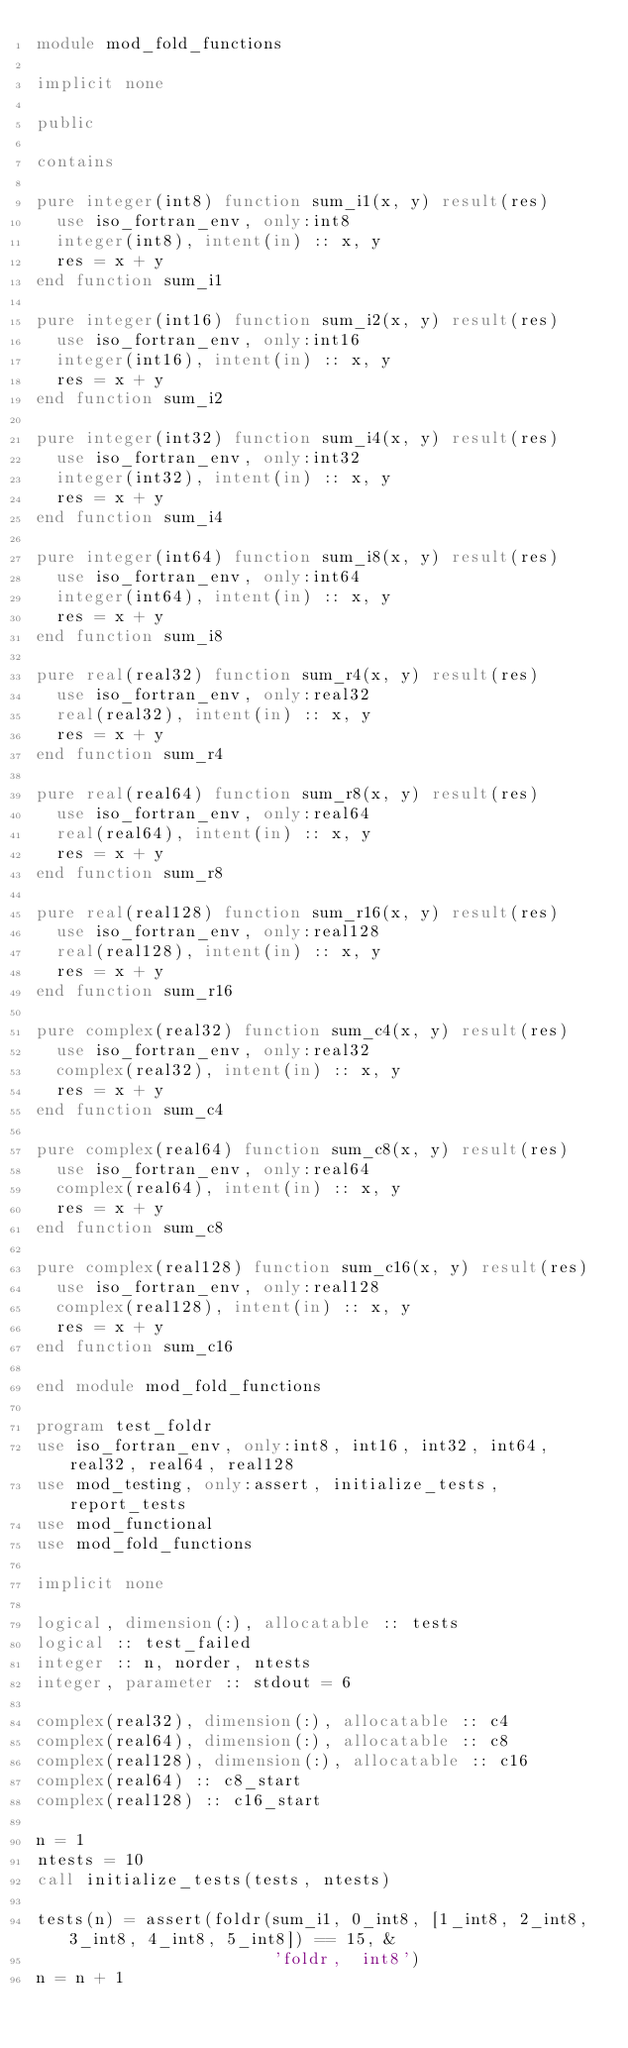<code> <loc_0><loc_0><loc_500><loc_500><_FORTRAN_>module mod_fold_functions

implicit none

public

contains

pure integer(int8) function sum_i1(x, y) result(res)
  use iso_fortran_env, only:int8
  integer(int8), intent(in) :: x, y
  res = x + y
end function sum_i1

pure integer(int16) function sum_i2(x, y) result(res)
  use iso_fortran_env, only:int16
  integer(int16), intent(in) :: x, y
  res = x + y
end function sum_i2
  
pure integer(int32) function sum_i4(x, y) result(res)
  use iso_fortran_env, only:int32
  integer(int32), intent(in) :: x, y
  res = x + y
end function sum_i4
  
pure integer(int64) function sum_i8(x, y) result(res)
  use iso_fortran_env, only:int64
  integer(int64), intent(in) :: x, y
  res = x + y
end function sum_i8
  
pure real(real32) function sum_r4(x, y) result(res)
  use iso_fortran_env, only:real32
  real(real32), intent(in) :: x, y
  res = x + y
end function sum_r4
  
pure real(real64) function sum_r8(x, y) result(res)
  use iso_fortran_env, only:real64
  real(real64), intent(in) :: x, y
  res = x + y
end function sum_r8
  
pure real(real128) function sum_r16(x, y) result(res)
  use iso_fortran_env, only:real128
  real(real128), intent(in) :: x, y
  res = x + y
end function sum_r16
 
pure complex(real32) function sum_c4(x, y) result(res)
  use iso_fortran_env, only:real32
  complex(real32), intent(in) :: x, y
  res = x + y
end function sum_c4

pure complex(real64) function sum_c8(x, y) result(res)
  use iso_fortran_env, only:real64
  complex(real64), intent(in) :: x, y
  res = x + y
end function sum_c8

pure complex(real128) function sum_c16(x, y) result(res)
  use iso_fortran_env, only:real128
  complex(real128), intent(in) :: x, y
  res = x + y
end function sum_c16
 
end module mod_fold_functions

program test_foldr
use iso_fortran_env, only:int8, int16, int32, int64, real32, real64, real128
use mod_testing, only:assert, initialize_tests, report_tests
use mod_functional
use mod_fold_functions

implicit none

logical, dimension(:), allocatable :: tests
logical :: test_failed
integer :: n, norder, ntests
integer, parameter :: stdout = 6

complex(real32), dimension(:), allocatable :: c4
complex(real64), dimension(:), allocatable :: c8
complex(real128), dimension(:), allocatable :: c16
complex(real64) :: c8_start
complex(real128) :: c16_start

n = 1
ntests = 10
call initialize_tests(tests, ntests)

tests(n) = assert(foldr(sum_i1, 0_int8, [1_int8, 2_int8, 3_int8, 4_int8, 5_int8]) == 15, &
                        'foldr,  int8')
n = n + 1
</code> 